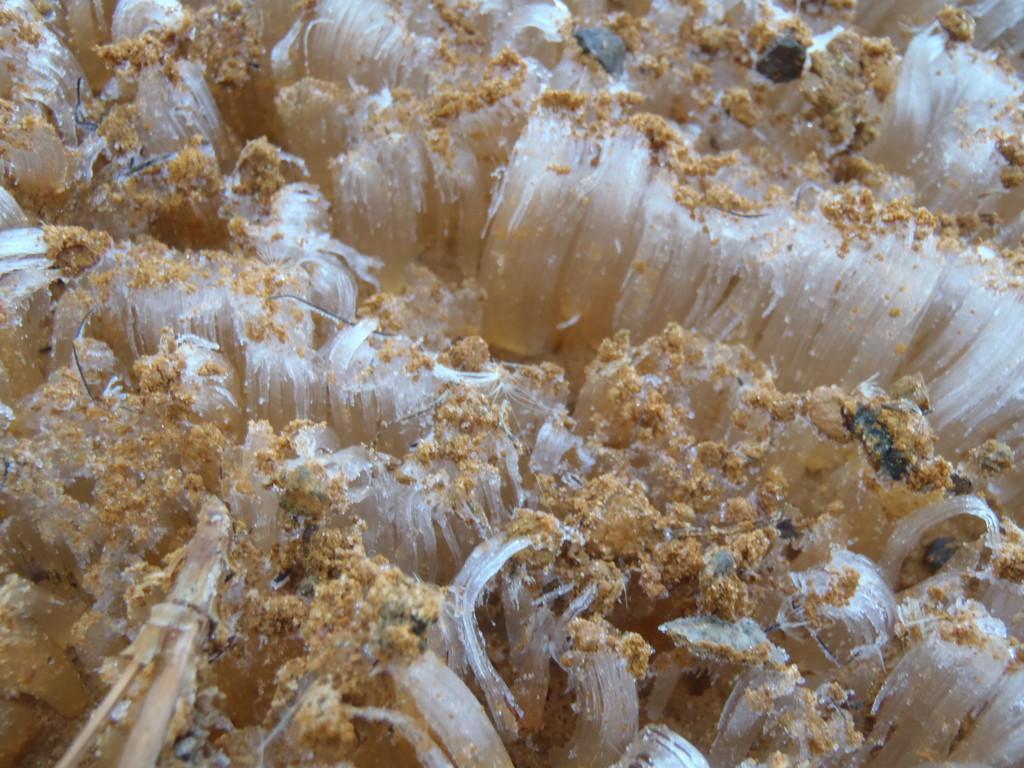In one or two sentences, can you explain what this image depicts? In this picture we can see corals. 